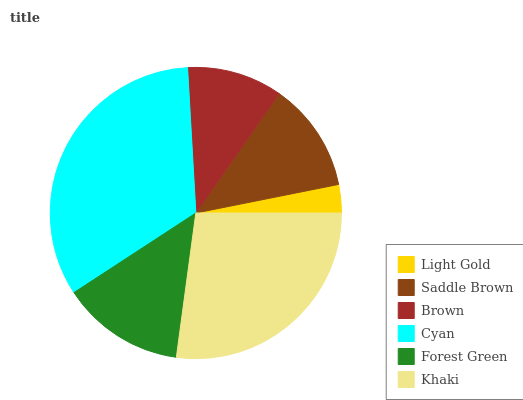Is Light Gold the minimum?
Answer yes or no. Yes. Is Cyan the maximum?
Answer yes or no. Yes. Is Saddle Brown the minimum?
Answer yes or no. No. Is Saddle Brown the maximum?
Answer yes or no. No. Is Saddle Brown greater than Light Gold?
Answer yes or no. Yes. Is Light Gold less than Saddle Brown?
Answer yes or no. Yes. Is Light Gold greater than Saddle Brown?
Answer yes or no. No. Is Saddle Brown less than Light Gold?
Answer yes or no. No. Is Forest Green the high median?
Answer yes or no. Yes. Is Saddle Brown the low median?
Answer yes or no. Yes. Is Brown the high median?
Answer yes or no. No. Is Cyan the low median?
Answer yes or no. No. 